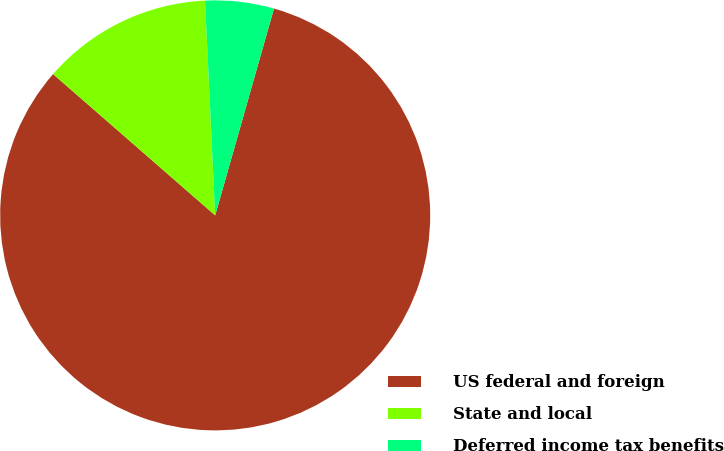Convert chart to OTSL. <chart><loc_0><loc_0><loc_500><loc_500><pie_chart><fcel>US federal and foreign<fcel>State and local<fcel>Deferred income tax benefits<nl><fcel>82.0%<fcel>12.84%<fcel>5.16%<nl></chart> 